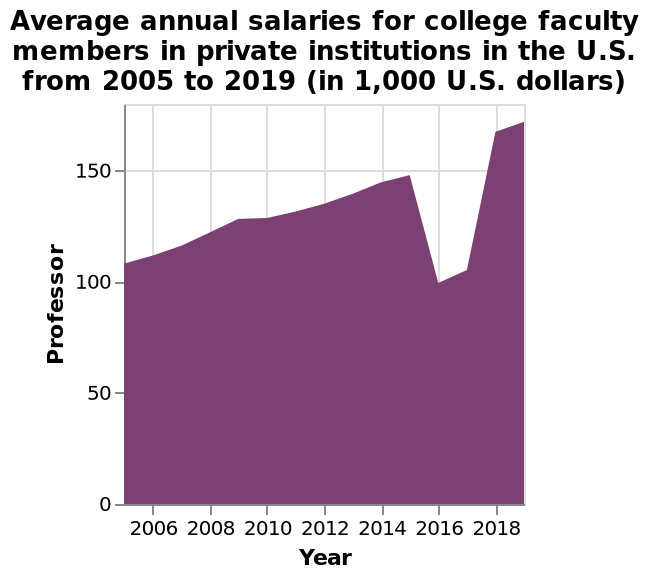<image>
Describe the following image in detail Here a area chart is labeled Average annual salaries for college faculty members in private institutions in the U.S. from 2005 to 2019 (in 1,000 U.S. dollars). The y-axis shows Professor while the x-axis plots Year. How low did the graph drop in 2016?  The graph dropped to a low of 100 in 2016. 